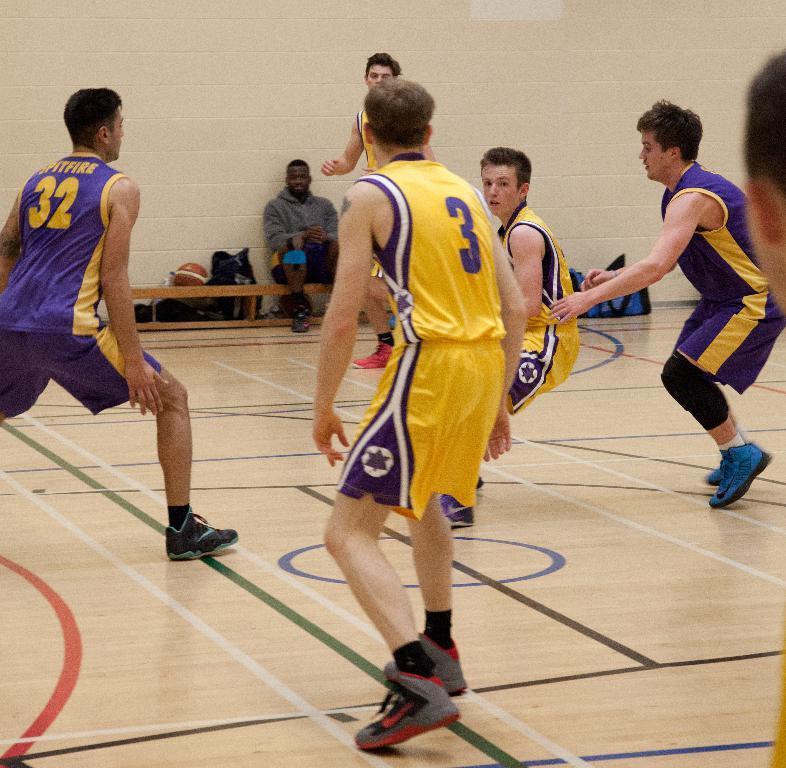Please provide a concise description of this image. In the picture we can see a sports surface floor on it, we can see some men are in a sportswear and running here and there and in the background, we can see a man sitting on the bench near the wall and beside the man we can see some things are placed. 